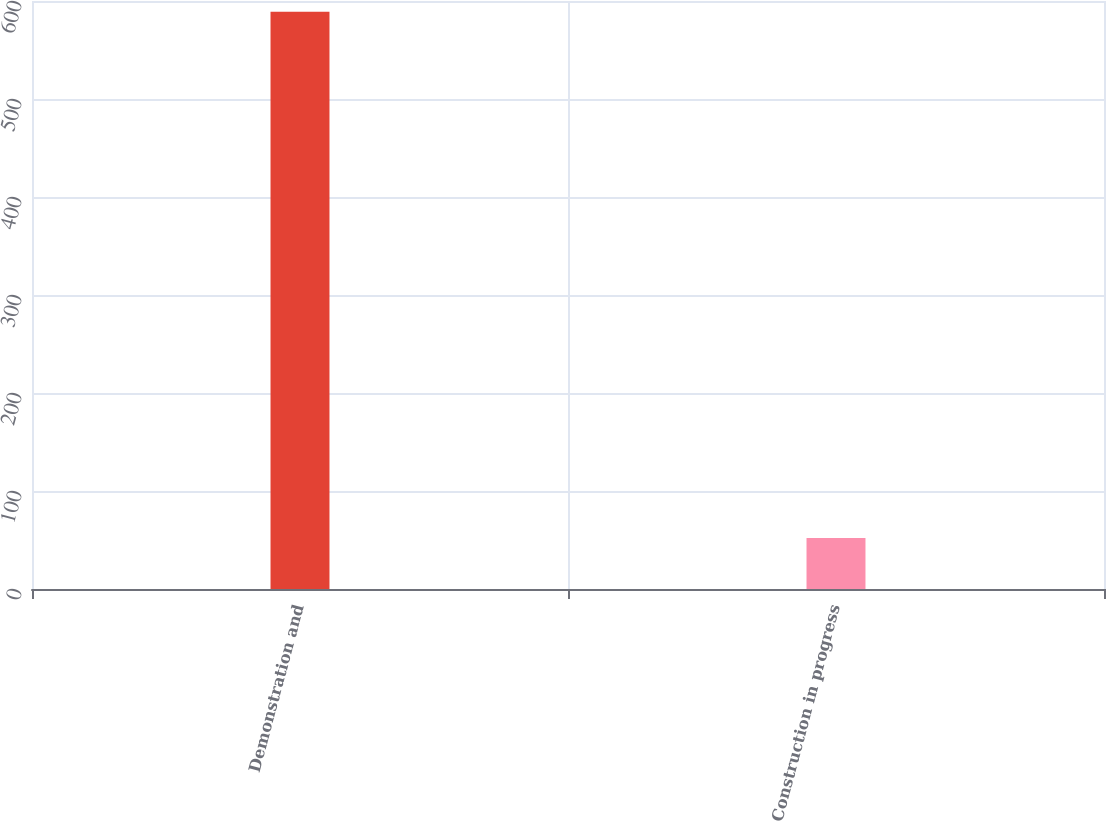Convert chart. <chart><loc_0><loc_0><loc_500><loc_500><bar_chart><fcel>Demonstration and<fcel>Construction in progress<nl><fcel>589<fcel>52<nl></chart> 